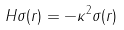Convert formula to latex. <formula><loc_0><loc_0><loc_500><loc_500>H \sigma ( r ) = - \kappa ^ { 2 } \sigma ( r )</formula> 